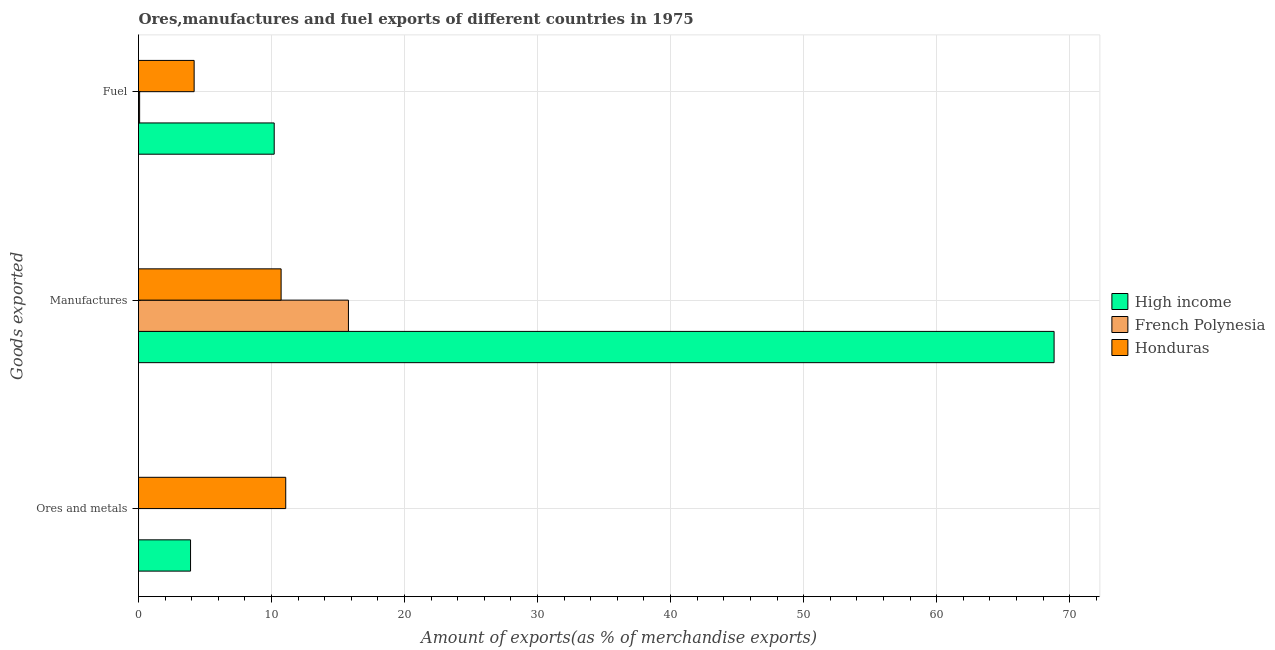How many different coloured bars are there?
Provide a short and direct response. 3. Are the number of bars on each tick of the Y-axis equal?
Offer a very short reply. Yes. How many bars are there on the 2nd tick from the top?
Your answer should be very brief. 3. What is the label of the 1st group of bars from the top?
Keep it short and to the point. Fuel. What is the percentage of ores and metals exports in Honduras?
Your response must be concise. 11.07. Across all countries, what is the maximum percentage of manufactures exports?
Keep it short and to the point. 68.83. Across all countries, what is the minimum percentage of fuel exports?
Your answer should be compact. 0.08. In which country was the percentage of ores and metals exports maximum?
Give a very brief answer. Honduras. In which country was the percentage of manufactures exports minimum?
Offer a terse response. Honduras. What is the total percentage of ores and metals exports in the graph?
Give a very brief answer. 14.98. What is the difference between the percentage of fuel exports in French Polynesia and that in Honduras?
Your response must be concise. -4.1. What is the difference between the percentage of fuel exports in Honduras and the percentage of ores and metals exports in High income?
Your answer should be very brief. 0.27. What is the average percentage of fuel exports per country?
Your response must be concise. 4.82. What is the difference between the percentage of ores and metals exports and percentage of fuel exports in High income?
Provide a short and direct response. -6.29. In how many countries, is the percentage of ores and metals exports greater than 20 %?
Make the answer very short. 0. What is the ratio of the percentage of fuel exports in French Polynesia to that in High income?
Provide a succinct answer. 0.01. What is the difference between the highest and the second highest percentage of ores and metals exports?
Give a very brief answer. 7.16. What is the difference between the highest and the lowest percentage of ores and metals exports?
Make the answer very short. 11.07. What does the 2nd bar from the top in Ores and metals represents?
Make the answer very short. French Polynesia. What does the 1st bar from the bottom in Manufactures represents?
Ensure brevity in your answer.  High income. Are all the bars in the graph horizontal?
Provide a short and direct response. Yes. Does the graph contain any zero values?
Make the answer very short. No. Does the graph contain grids?
Provide a short and direct response. Yes. What is the title of the graph?
Ensure brevity in your answer.  Ores,manufactures and fuel exports of different countries in 1975. What is the label or title of the X-axis?
Make the answer very short. Amount of exports(as % of merchandise exports). What is the label or title of the Y-axis?
Your answer should be compact. Goods exported. What is the Amount of exports(as % of merchandise exports) in High income in Ores and metals?
Offer a very short reply. 3.91. What is the Amount of exports(as % of merchandise exports) in French Polynesia in Ores and metals?
Your answer should be compact. 0. What is the Amount of exports(as % of merchandise exports) of Honduras in Ores and metals?
Provide a short and direct response. 11.07. What is the Amount of exports(as % of merchandise exports) of High income in Manufactures?
Offer a very short reply. 68.83. What is the Amount of exports(as % of merchandise exports) of French Polynesia in Manufactures?
Offer a very short reply. 15.78. What is the Amount of exports(as % of merchandise exports) of Honduras in Manufactures?
Offer a very short reply. 10.72. What is the Amount of exports(as % of merchandise exports) of High income in Fuel?
Keep it short and to the point. 10.2. What is the Amount of exports(as % of merchandise exports) of French Polynesia in Fuel?
Provide a short and direct response. 0.08. What is the Amount of exports(as % of merchandise exports) of Honduras in Fuel?
Give a very brief answer. 4.18. Across all Goods exported, what is the maximum Amount of exports(as % of merchandise exports) in High income?
Ensure brevity in your answer.  68.83. Across all Goods exported, what is the maximum Amount of exports(as % of merchandise exports) of French Polynesia?
Your answer should be compact. 15.78. Across all Goods exported, what is the maximum Amount of exports(as % of merchandise exports) in Honduras?
Provide a short and direct response. 11.07. Across all Goods exported, what is the minimum Amount of exports(as % of merchandise exports) of High income?
Keep it short and to the point. 3.91. Across all Goods exported, what is the minimum Amount of exports(as % of merchandise exports) of French Polynesia?
Keep it short and to the point. 0. Across all Goods exported, what is the minimum Amount of exports(as % of merchandise exports) in Honduras?
Make the answer very short. 4.18. What is the total Amount of exports(as % of merchandise exports) in High income in the graph?
Keep it short and to the point. 82.94. What is the total Amount of exports(as % of merchandise exports) in French Polynesia in the graph?
Make the answer very short. 15.87. What is the total Amount of exports(as % of merchandise exports) in Honduras in the graph?
Your answer should be compact. 25.97. What is the difference between the Amount of exports(as % of merchandise exports) in High income in Ores and metals and that in Manufactures?
Ensure brevity in your answer.  -64.92. What is the difference between the Amount of exports(as % of merchandise exports) in French Polynesia in Ores and metals and that in Manufactures?
Ensure brevity in your answer.  -15.78. What is the difference between the Amount of exports(as % of merchandise exports) of Honduras in Ores and metals and that in Manufactures?
Offer a very short reply. 0.35. What is the difference between the Amount of exports(as % of merchandise exports) in High income in Ores and metals and that in Fuel?
Your response must be concise. -6.29. What is the difference between the Amount of exports(as % of merchandise exports) of French Polynesia in Ores and metals and that in Fuel?
Your answer should be very brief. -0.08. What is the difference between the Amount of exports(as % of merchandise exports) in Honduras in Ores and metals and that in Fuel?
Ensure brevity in your answer.  6.89. What is the difference between the Amount of exports(as % of merchandise exports) in High income in Manufactures and that in Fuel?
Provide a succinct answer. 58.63. What is the difference between the Amount of exports(as % of merchandise exports) in French Polynesia in Manufactures and that in Fuel?
Your answer should be very brief. 15.7. What is the difference between the Amount of exports(as % of merchandise exports) of Honduras in Manufactures and that in Fuel?
Keep it short and to the point. 6.54. What is the difference between the Amount of exports(as % of merchandise exports) in High income in Ores and metals and the Amount of exports(as % of merchandise exports) in French Polynesia in Manufactures?
Your answer should be very brief. -11.87. What is the difference between the Amount of exports(as % of merchandise exports) of High income in Ores and metals and the Amount of exports(as % of merchandise exports) of Honduras in Manufactures?
Offer a terse response. -6.81. What is the difference between the Amount of exports(as % of merchandise exports) in French Polynesia in Ores and metals and the Amount of exports(as % of merchandise exports) in Honduras in Manufactures?
Offer a very short reply. -10.72. What is the difference between the Amount of exports(as % of merchandise exports) in High income in Ores and metals and the Amount of exports(as % of merchandise exports) in French Polynesia in Fuel?
Offer a very short reply. 3.83. What is the difference between the Amount of exports(as % of merchandise exports) of High income in Ores and metals and the Amount of exports(as % of merchandise exports) of Honduras in Fuel?
Offer a terse response. -0.27. What is the difference between the Amount of exports(as % of merchandise exports) of French Polynesia in Ores and metals and the Amount of exports(as % of merchandise exports) of Honduras in Fuel?
Ensure brevity in your answer.  -4.18. What is the difference between the Amount of exports(as % of merchandise exports) in High income in Manufactures and the Amount of exports(as % of merchandise exports) in French Polynesia in Fuel?
Offer a very short reply. 68.75. What is the difference between the Amount of exports(as % of merchandise exports) in High income in Manufactures and the Amount of exports(as % of merchandise exports) in Honduras in Fuel?
Keep it short and to the point. 64.65. What is the difference between the Amount of exports(as % of merchandise exports) in French Polynesia in Manufactures and the Amount of exports(as % of merchandise exports) in Honduras in Fuel?
Your response must be concise. 11.6. What is the average Amount of exports(as % of merchandise exports) in High income per Goods exported?
Provide a short and direct response. 27.65. What is the average Amount of exports(as % of merchandise exports) of French Polynesia per Goods exported?
Provide a short and direct response. 5.29. What is the average Amount of exports(as % of merchandise exports) in Honduras per Goods exported?
Your answer should be compact. 8.66. What is the difference between the Amount of exports(as % of merchandise exports) of High income and Amount of exports(as % of merchandise exports) of French Polynesia in Ores and metals?
Your answer should be compact. 3.91. What is the difference between the Amount of exports(as % of merchandise exports) of High income and Amount of exports(as % of merchandise exports) of Honduras in Ores and metals?
Provide a short and direct response. -7.16. What is the difference between the Amount of exports(as % of merchandise exports) of French Polynesia and Amount of exports(as % of merchandise exports) of Honduras in Ores and metals?
Offer a very short reply. -11.07. What is the difference between the Amount of exports(as % of merchandise exports) in High income and Amount of exports(as % of merchandise exports) in French Polynesia in Manufactures?
Offer a terse response. 53.05. What is the difference between the Amount of exports(as % of merchandise exports) of High income and Amount of exports(as % of merchandise exports) of Honduras in Manufactures?
Provide a succinct answer. 58.11. What is the difference between the Amount of exports(as % of merchandise exports) in French Polynesia and Amount of exports(as % of merchandise exports) in Honduras in Manufactures?
Make the answer very short. 5.06. What is the difference between the Amount of exports(as % of merchandise exports) of High income and Amount of exports(as % of merchandise exports) of French Polynesia in Fuel?
Your answer should be compact. 10.12. What is the difference between the Amount of exports(as % of merchandise exports) in High income and Amount of exports(as % of merchandise exports) in Honduras in Fuel?
Provide a short and direct response. 6.02. What is the difference between the Amount of exports(as % of merchandise exports) in French Polynesia and Amount of exports(as % of merchandise exports) in Honduras in Fuel?
Your answer should be very brief. -4.1. What is the ratio of the Amount of exports(as % of merchandise exports) in High income in Ores and metals to that in Manufactures?
Offer a terse response. 0.06. What is the ratio of the Amount of exports(as % of merchandise exports) of Honduras in Ores and metals to that in Manufactures?
Offer a terse response. 1.03. What is the ratio of the Amount of exports(as % of merchandise exports) of High income in Ores and metals to that in Fuel?
Give a very brief answer. 0.38. What is the ratio of the Amount of exports(as % of merchandise exports) of French Polynesia in Ores and metals to that in Fuel?
Keep it short and to the point. 0. What is the ratio of the Amount of exports(as % of merchandise exports) in Honduras in Ores and metals to that in Fuel?
Provide a short and direct response. 2.65. What is the ratio of the Amount of exports(as % of merchandise exports) in High income in Manufactures to that in Fuel?
Give a very brief answer. 6.75. What is the ratio of the Amount of exports(as % of merchandise exports) in French Polynesia in Manufactures to that in Fuel?
Give a very brief answer. 189.13. What is the ratio of the Amount of exports(as % of merchandise exports) of Honduras in Manufactures to that in Fuel?
Offer a very short reply. 2.56. What is the difference between the highest and the second highest Amount of exports(as % of merchandise exports) of High income?
Provide a short and direct response. 58.63. What is the difference between the highest and the second highest Amount of exports(as % of merchandise exports) of French Polynesia?
Offer a terse response. 15.7. What is the difference between the highest and the second highest Amount of exports(as % of merchandise exports) of Honduras?
Your answer should be very brief. 0.35. What is the difference between the highest and the lowest Amount of exports(as % of merchandise exports) of High income?
Keep it short and to the point. 64.92. What is the difference between the highest and the lowest Amount of exports(as % of merchandise exports) in French Polynesia?
Your response must be concise. 15.78. What is the difference between the highest and the lowest Amount of exports(as % of merchandise exports) of Honduras?
Ensure brevity in your answer.  6.89. 